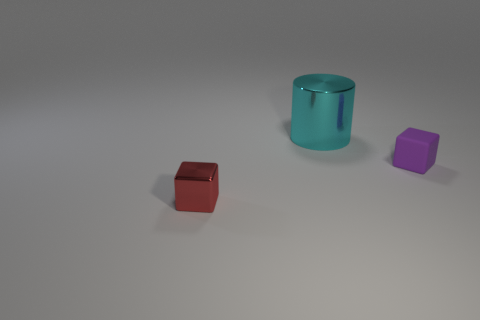Is there a small red object that is in front of the metallic thing to the right of the red shiny object?
Your answer should be very brief. Yes. How many objects are either tiny objects that are left of the large cylinder or large cyan things?
Your response must be concise. 2. Is there anything else that has the same size as the cyan thing?
Ensure brevity in your answer.  No. There is a small object that is right of the metal thing that is to the right of the red metal thing; what is its material?
Your response must be concise. Rubber. Are there the same number of small metallic things in front of the large cyan thing and cyan cylinders right of the rubber cube?
Ensure brevity in your answer.  No. How many things are small cubes left of the cyan thing or cubes that are left of the tiny purple rubber block?
Ensure brevity in your answer.  1. What is the thing that is both behind the small red metallic cube and in front of the large cylinder made of?
Your response must be concise. Rubber. How big is the shiny thing that is behind the tiny block that is behind the metal object that is on the left side of the big metal thing?
Your answer should be very brief. Large. Is the number of tiny green metal cylinders greater than the number of red shiny things?
Provide a succinct answer. No. Does the small cube that is on the left side of the large cyan object have the same material as the purple object?
Provide a short and direct response. No. 